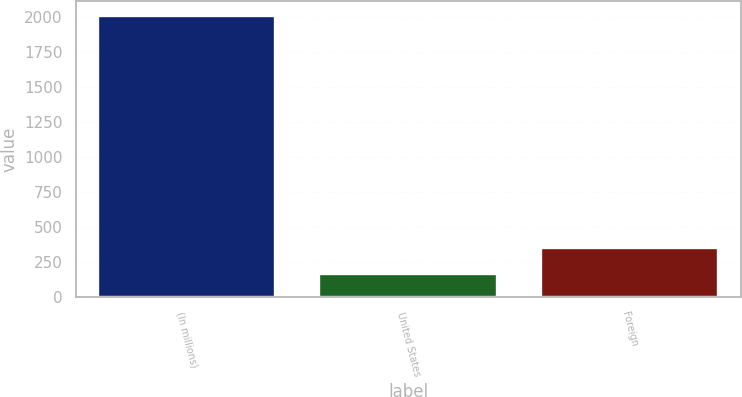<chart> <loc_0><loc_0><loc_500><loc_500><bar_chart><fcel>(In millions)<fcel>United States<fcel>Foreign<nl><fcel>2007<fcel>165<fcel>349.2<nl></chart> 